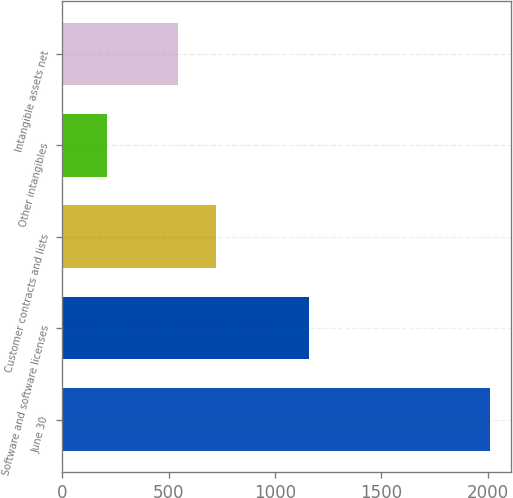<chart> <loc_0><loc_0><loc_500><loc_500><bar_chart><fcel>June 30<fcel>Software and software licenses<fcel>Customer contracts and lists<fcel>Other intangibles<fcel>Intangible assets net<nl><fcel>2010<fcel>1160<fcel>722.45<fcel>209.5<fcel>542.4<nl></chart> 